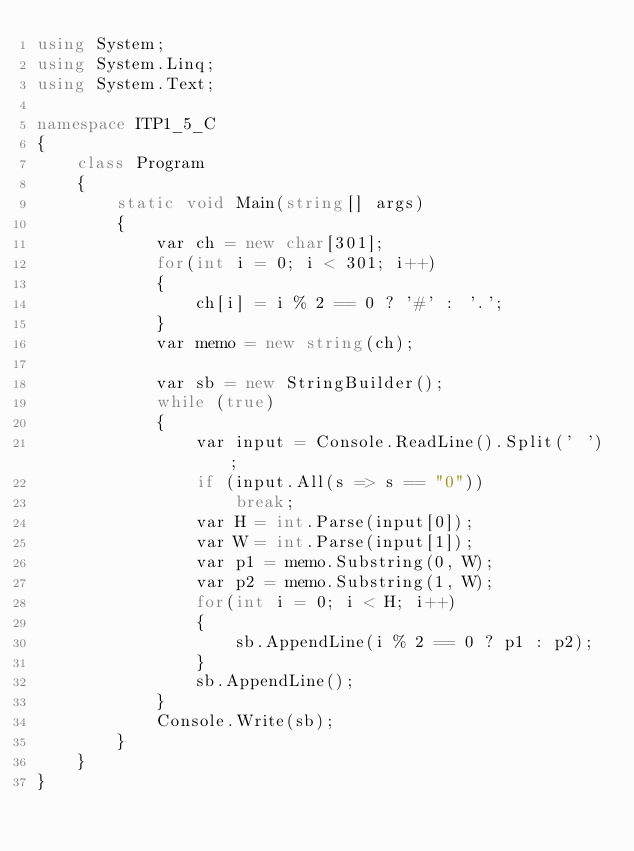Convert code to text. <code><loc_0><loc_0><loc_500><loc_500><_C#_>using System;
using System.Linq;
using System.Text;

namespace ITP1_5_C
{
    class Program
    {
        static void Main(string[] args)
        {
            var ch = new char[301];
            for(int i = 0; i < 301; i++)
            {
                ch[i] = i % 2 == 0 ? '#' : '.';
            }
            var memo = new string(ch);

            var sb = new StringBuilder();
            while (true)
            {
                var input = Console.ReadLine().Split(' ');
                if (input.All(s => s == "0"))
                    break;
                var H = int.Parse(input[0]);
                var W = int.Parse(input[1]);
                var p1 = memo.Substring(0, W);
                var p2 = memo.Substring(1, W);
                for(int i = 0; i < H; i++)
                {
                    sb.AppendLine(i % 2 == 0 ? p1 : p2);
                }
                sb.AppendLine();
            }
            Console.Write(sb);
        }
    }
}</code> 